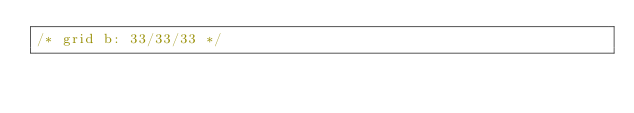<code> <loc_0><loc_0><loc_500><loc_500><_CSS_>/* grid b: 33/33/33 */</code> 